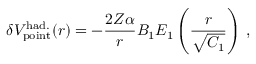<formula> <loc_0><loc_0><loc_500><loc_500>\delta { V } _ { p o i n t } ^ { h a d . } ( r ) = - \frac { 2 Z \alpha } { r } B _ { 1 } E _ { 1 } \left ( \frac { r } { \sqrt { C _ { 1 } } } \right ) \, ,</formula> 